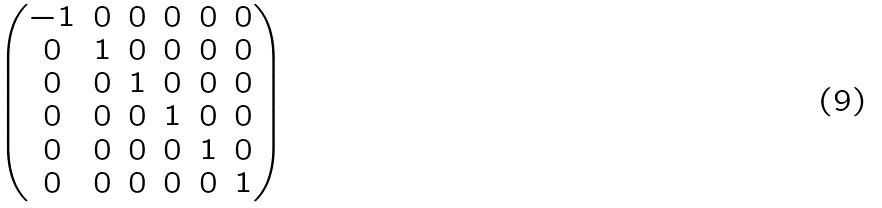<formula> <loc_0><loc_0><loc_500><loc_500>\begin{pmatrix} - 1 & 0 & 0 & 0 & 0 & 0 \\ 0 & 1 & 0 & 0 & 0 & 0 \\ 0 & 0 & 1 & 0 & 0 & 0 \\ 0 & 0 & 0 & 1 & 0 & 0 \\ 0 & 0 & 0 & 0 & 1 & 0 \\ 0 & 0 & 0 & 0 & 0 & 1 \\ \end{pmatrix}</formula> 